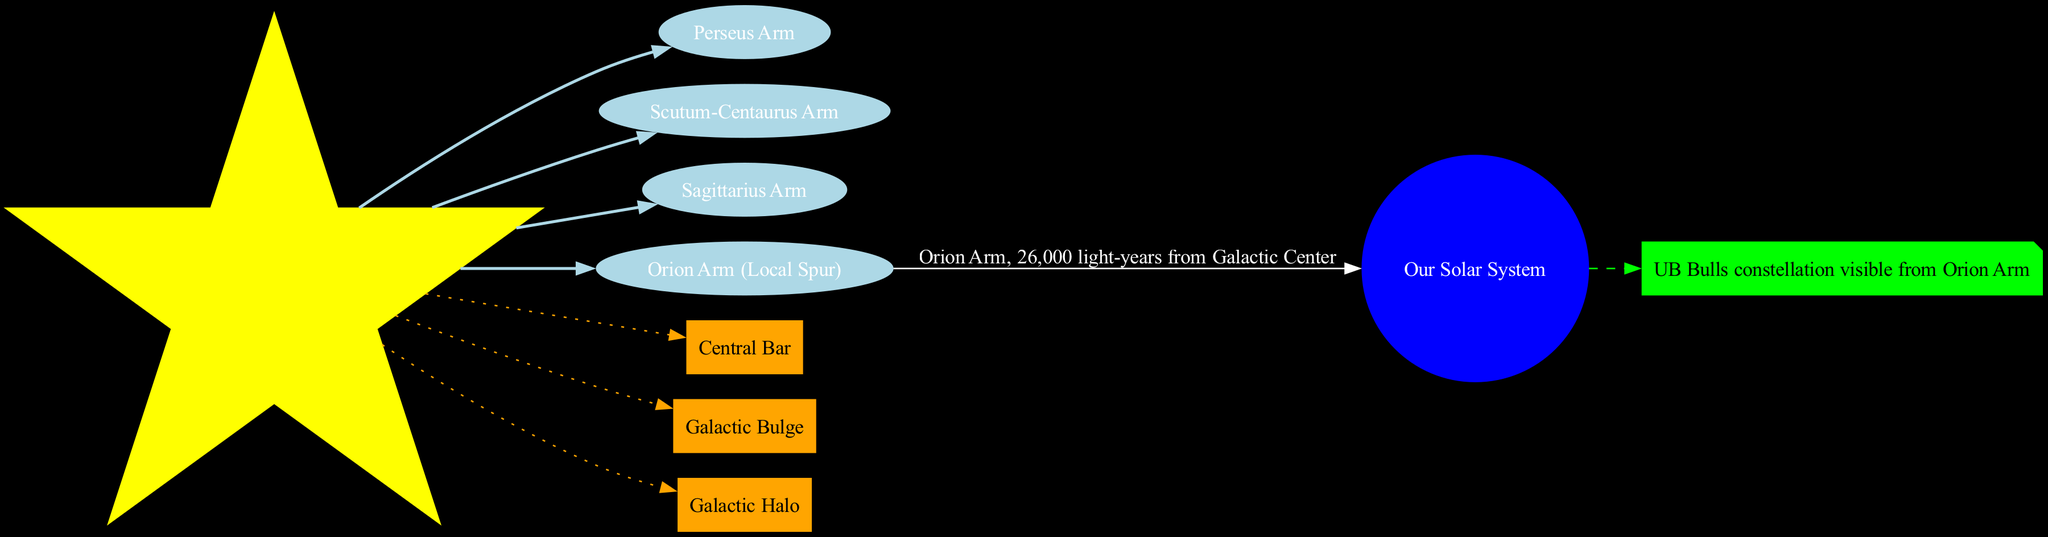What is the name of the central feature of the Milky Way galaxy? The diagram indicates that the central feature is labeled as "Galactic Center." This is a direct observation from the node labeled "center."
Answer: Galactic Center How many spiral arms are shown in the diagram? The diagram lists four spiral arms: Perseus Arm, Scutum-Centaurus Arm, Sagittarius Arm, and Orion Arm (Local Spur). Thus, the total count is four.
Answer: 4 What is the location of our solar system? The diagram states that our solar system is located in the "Orion Arm" and is specifically described as being "26,000 light-years from Galactic Center." This information is derived from the node connected to the solar system node.
Answer: Orion Arm, 26,000 light-years from Galactic Center Which arm does the solar system belong to? According to the diagram, the solar system is specifically mentioned to be in the "Orion Arm." This is connected directly to the solar system node.
Answer: Orion Arm What color represents the Galactic Halo in the diagram? While the diagram does not provide a specific color node for the Galactic Halo, we understand that it is inferred from the context where all other features like the Galactic Center and spiral arms are visually distinct. However, specific color representation for the halo is not mentioned in the diagram.
Answer: Not specified Which feature is connected to the solar system with a dashed edge? The diagram has a dashed edge leading from the solar system node to a note that contains the fun fact about the UB Bulls constellation. Thus, this connection is easily identifiable.
Answer: UB Bulls constellation visible from Orion Arm What is the purpose of the dotted edges in the diagram? The dotted edges connect the Galactic Center to the features listed: Central Bar, Galactic Bulge, and Galactic Halo. This indicates that these features have a relationship with the center of the galaxy, highlighting their significance in the structure of the Milky Way.
Answer: To indicate relationships between the Galactic Center and features How many features are illustrated in the diagram? The diagram presents three features: Central Bar, Galactic Bulge, and Galactic Halo. This count can be obtained by counting each distinct node labeled as a feature.
Answer: 3 